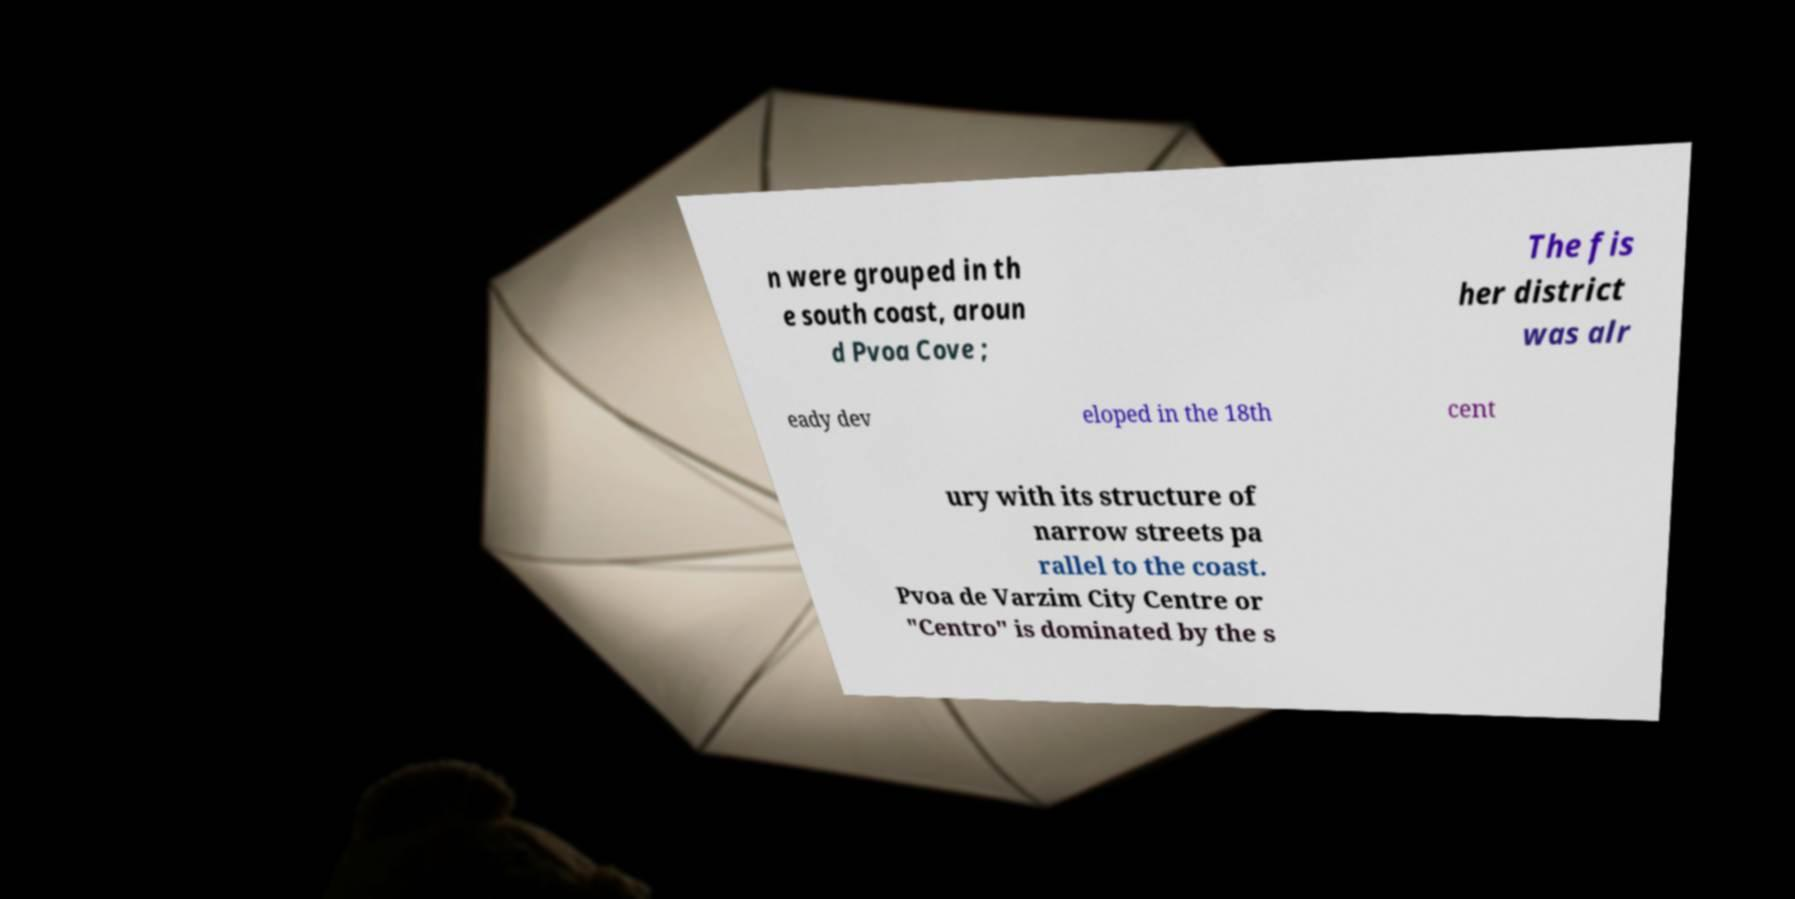There's text embedded in this image that I need extracted. Can you transcribe it verbatim? n were grouped in th e south coast, aroun d Pvoa Cove ; The fis her district was alr eady dev eloped in the 18th cent ury with its structure of narrow streets pa rallel to the coast. Pvoa de Varzim City Centre or "Centro" is dominated by the s 